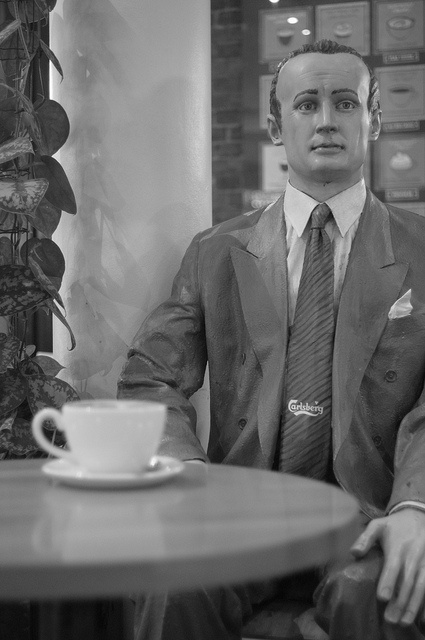Describe the objects in this image and their specific colors. I can see people in black, gray, darkgray, and lightgray tones, dining table in gray, darkgray, and black tones, tie in black, gray, darkgray, and lightgray tones, and cup in black, darkgray, lightgray, and gray tones in this image. 